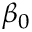<formula> <loc_0><loc_0><loc_500><loc_500>\beta _ { 0 }</formula> 